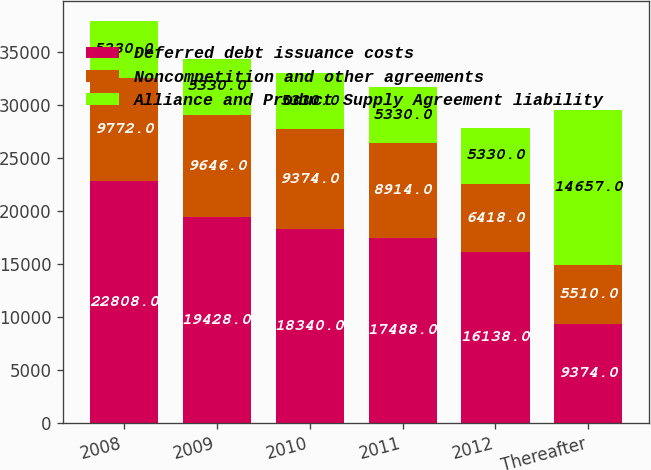Convert chart to OTSL. <chart><loc_0><loc_0><loc_500><loc_500><stacked_bar_chart><ecel><fcel>2008<fcel>2009<fcel>2010<fcel>2011<fcel>2012<fcel>Thereafter<nl><fcel>Deferred debt issuance costs<fcel>22808<fcel>19428<fcel>18340<fcel>17488<fcel>16138<fcel>9374<nl><fcel>Noncompetition and other agreements<fcel>9772<fcel>9646<fcel>9374<fcel>8914<fcel>6418<fcel>5510<nl><fcel>Alliance and Product Supply Agreement liability<fcel>5330<fcel>5330<fcel>5330<fcel>5330<fcel>5330<fcel>14657<nl></chart> 